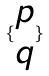<formula> <loc_0><loc_0><loc_500><loc_500>\{ \begin{matrix} p \\ q \end{matrix} \}</formula> 